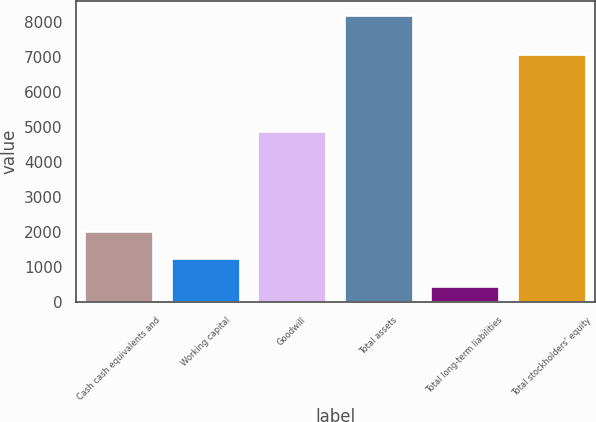<chart> <loc_0><loc_0><loc_500><loc_500><bar_chart><fcel>Cash cash equivalents and<fcel>Working capital<fcel>Goodwill<fcel>Total assets<fcel>Total long-term liabilities<fcel>Total stockholders' equity<nl><fcel>2047.1<fcel>1261.4<fcel>4879.7<fcel>8183.6<fcel>468<fcel>7088.2<nl></chart> 